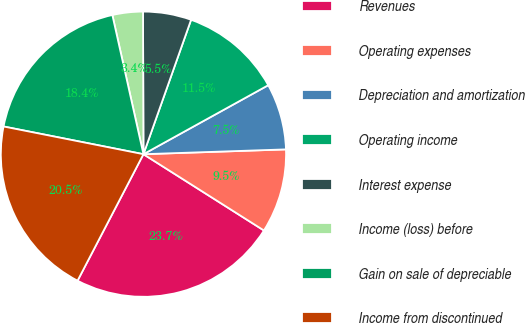Convert chart to OTSL. <chart><loc_0><loc_0><loc_500><loc_500><pie_chart><fcel>Revenues<fcel>Operating expenses<fcel>Depreciation and amortization<fcel>Operating income<fcel>Interest expense<fcel>Income (loss) before<fcel>Gain on sale of depreciable<fcel>Income from discontinued<nl><fcel>23.66%<fcel>9.52%<fcel>7.5%<fcel>11.54%<fcel>5.47%<fcel>3.45%<fcel>18.39%<fcel>20.47%<nl></chart> 